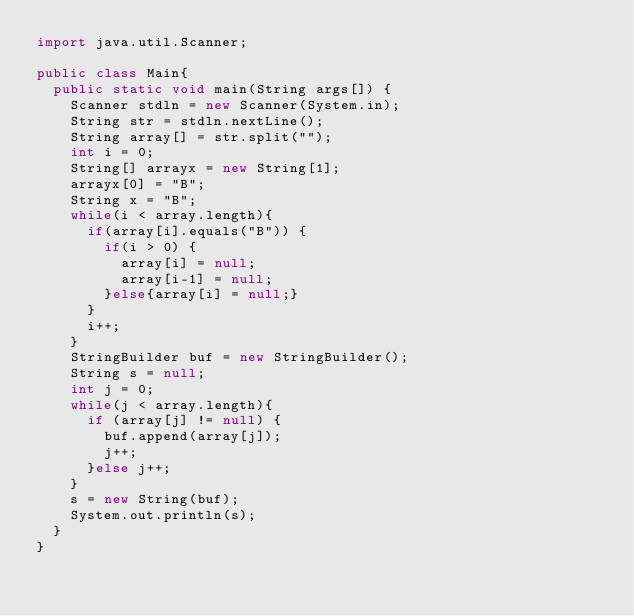<code> <loc_0><loc_0><loc_500><loc_500><_Java_>import java.util.Scanner;

public class Main{
  public static void main(String args[]) {
    Scanner stdln = new Scanner(System.in);
    String str = stdln.nextLine();
    String array[] = str.split("");
    int i = 0;
    String[] arrayx = new String[1];
    arrayx[0] = "B";
    String x = "B";
    while(i < array.length){
      if(array[i].equals("B")) {
        if(i > 0) {
          array[i] = null;
          array[i-1] = null;
        }else{array[i] = null;}
      }
      i++;
    }
    StringBuilder buf = new StringBuilder();
    String s = null;
    int j = 0;
    while(j < array.length){
      if (array[j] != null) {
        buf.append(array[j]);
        j++;
      }else j++;
    }
    s = new String(buf);
    System.out.println(s);
  }
}
</code> 